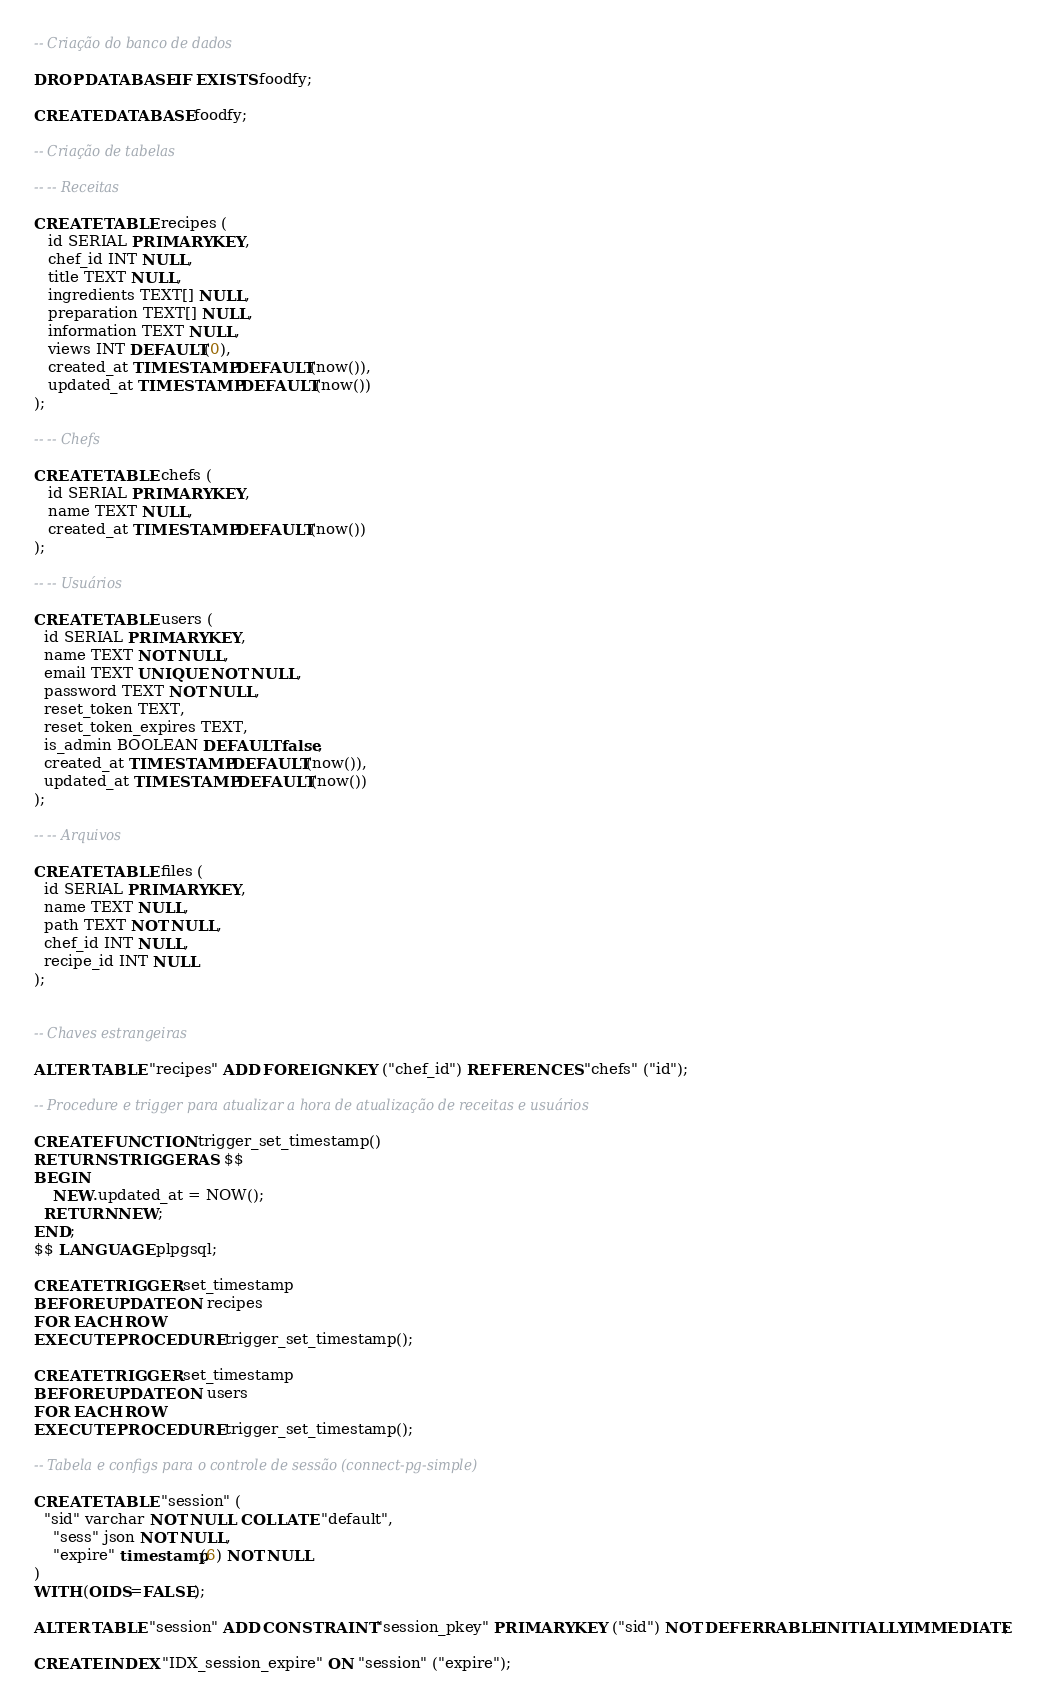<code> <loc_0><loc_0><loc_500><loc_500><_SQL_>-- Criação do banco de dados

DROP DATABASE IF EXISTS foodfy;

CREATE DATABASE foodfy;

-- Criação de tabelas

-- -- Receitas

CREATE TABLE recipes (
   id SERIAL PRIMARY KEY,
   chef_id INT NULL,
   title TEXT NULL,
   ingredients TEXT[] NULL,
   preparation TEXT[] NULL,
   information TEXT NULL,
   views INT DEFAULT(0),
   created_at TIMESTAMP DEFAULT(now()),
   updated_at TIMESTAMP DEFAULT(now())
);

-- -- Chefs

CREATE TABLE chefs (
   id SERIAL PRIMARY KEY,
   name TEXT NULL,
   created_at TIMESTAMP DEFAULT(now())
);

-- -- Usuários

CREATE TABLE users (
  id SERIAL PRIMARY KEY,
  name TEXT NOT NULL,
  email TEXT UNIQUE NOT NULL,
  password TEXT NOT NULL,
  reset_token TEXT,
  reset_token_expires TEXT,
  is_admin BOOLEAN DEFAULT false,
  created_at TIMESTAMP DEFAULT(now()),
  updated_at TIMESTAMP DEFAULT(now())
);

-- -- Arquivos

CREATE TABLE files (
  id SERIAL PRIMARY KEY,
  name TEXT NULL,
  path TEXT NOT NULL,
  chef_id INT NULL,
  recipe_id INT NULL
);


-- Chaves estrangeiras

ALTER TABLE "recipes" ADD FOREIGN KEY ("chef_id") REFERENCES "chefs" ("id");

-- Procedure e trigger para atualizar a hora de atualização de receitas e usuários

CREATE FUNCTION trigger_set_timestamp()
RETURNS TRIGGER AS $$
BEGIN
	NEW.updated_at = NOW();
  RETURN NEW;
END;
$$ LANGUAGE plpgsql;

CREATE TRIGGER set_timestamp
BEFORE UPDATE ON recipes
FOR EACH ROW
EXECUTE PROCEDURE trigger_set_timestamp();

CREATE TRIGGER set_timestamp
BEFORE UPDATE ON users
FOR EACH ROW
EXECUTE PROCEDURE trigger_set_timestamp();

-- Tabela e configs para o controle de sessão (connect-pg-simple)

CREATE TABLE "session" (
  "sid" varchar NOT NULL COLLATE "default",
	"sess" json NOT NULL,
	"expire" timestamp(6) NOT NULL
)
WITH (OIDS=FALSE);

ALTER TABLE "session" ADD CONSTRAINT "session_pkey" PRIMARY KEY ("sid") NOT DEFERRABLE INITIALLY IMMEDIATE;

CREATE INDEX "IDX_session_expire" ON "session" ("expire");</code> 